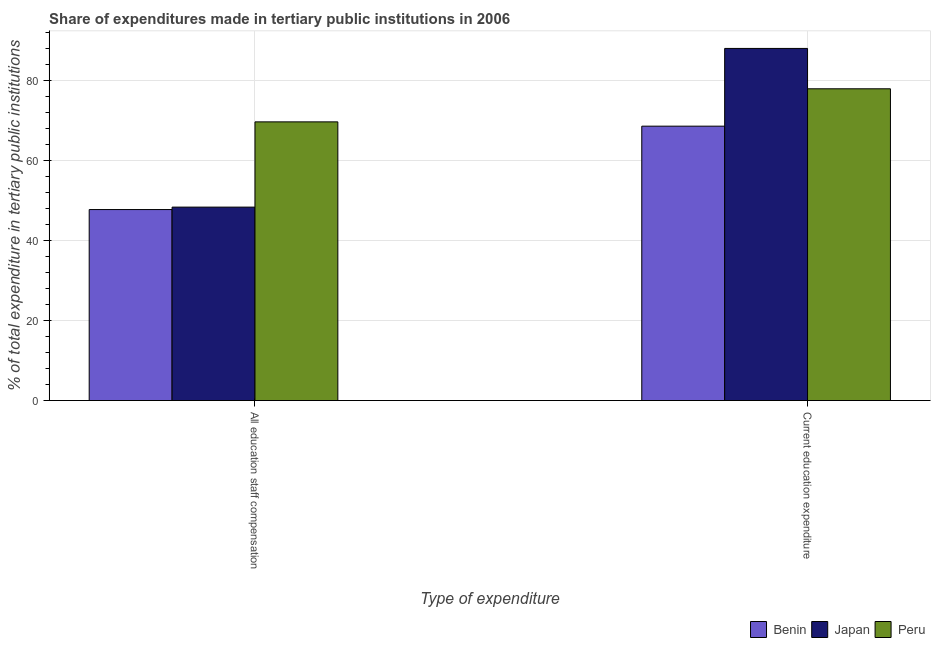How many different coloured bars are there?
Make the answer very short. 3. How many groups of bars are there?
Make the answer very short. 2. How many bars are there on the 1st tick from the left?
Give a very brief answer. 3. What is the label of the 2nd group of bars from the left?
Your answer should be compact. Current education expenditure. What is the expenditure in staff compensation in Benin?
Your answer should be very brief. 47.78. Across all countries, what is the maximum expenditure in staff compensation?
Provide a succinct answer. 69.72. Across all countries, what is the minimum expenditure in staff compensation?
Offer a very short reply. 47.78. In which country was the expenditure in education minimum?
Your answer should be very brief. Benin. What is the total expenditure in staff compensation in the graph?
Provide a short and direct response. 165.9. What is the difference between the expenditure in education in Peru and that in Benin?
Give a very brief answer. 9.35. What is the difference between the expenditure in education in Japan and the expenditure in staff compensation in Peru?
Offer a terse response. 18.37. What is the average expenditure in staff compensation per country?
Offer a very short reply. 55.3. What is the difference between the expenditure in staff compensation and expenditure in education in Peru?
Make the answer very short. -8.27. What is the ratio of the expenditure in staff compensation in Benin to that in Peru?
Make the answer very short. 0.69. In how many countries, is the expenditure in education greater than the average expenditure in education taken over all countries?
Make the answer very short. 1. What does the 3rd bar from the left in Current education expenditure represents?
Provide a succinct answer. Peru. What is the difference between two consecutive major ticks on the Y-axis?
Offer a very short reply. 20. Does the graph contain any zero values?
Your answer should be compact. No. Does the graph contain grids?
Your answer should be very brief. Yes. How are the legend labels stacked?
Your answer should be compact. Horizontal. What is the title of the graph?
Offer a very short reply. Share of expenditures made in tertiary public institutions in 2006. Does "Nigeria" appear as one of the legend labels in the graph?
Provide a succinct answer. No. What is the label or title of the X-axis?
Provide a short and direct response. Type of expenditure. What is the label or title of the Y-axis?
Your answer should be compact. % of total expenditure in tertiary public institutions. What is the % of total expenditure in tertiary public institutions in Benin in All education staff compensation?
Offer a terse response. 47.78. What is the % of total expenditure in tertiary public institutions of Japan in All education staff compensation?
Your answer should be compact. 48.4. What is the % of total expenditure in tertiary public institutions of Peru in All education staff compensation?
Ensure brevity in your answer.  69.72. What is the % of total expenditure in tertiary public institutions of Benin in Current education expenditure?
Offer a very short reply. 68.65. What is the % of total expenditure in tertiary public institutions of Japan in Current education expenditure?
Offer a terse response. 88.09. What is the % of total expenditure in tertiary public institutions of Peru in Current education expenditure?
Offer a very short reply. 77.99. Across all Type of expenditure, what is the maximum % of total expenditure in tertiary public institutions of Benin?
Ensure brevity in your answer.  68.65. Across all Type of expenditure, what is the maximum % of total expenditure in tertiary public institutions in Japan?
Provide a short and direct response. 88.09. Across all Type of expenditure, what is the maximum % of total expenditure in tertiary public institutions in Peru?
Your response must be concise. 77.99. Across all Type of expenditure, what is the minimum % of total expenditure in tertiary public institutions in Benin?
Give a very brief answer. 47.78. Across all Type of expenditure, what is the minimum % of total expenditure in tertiary public institutions of Japan?
Your answer should be very brief. 48.4. Across all Type of expenditure, what is the minimum % of total expenditure in tertiary public institutions in Peru?
Provide a short and direct response. 69.72. What is the total % of total expenditure in tertiary public institutions of Benin in the graph?
Offer a terse response. 116.43. What is the total % of total expenditure in tertiary public institutions in Japan in the graph?
Your answer should be compact. 136.49. What is the total % of total expenditure in tertiary public institutions in Peru in the graph?
Give a very brief answer. 147.71. What is the difference between the % of total expenditure in tertiary public institutions in Benin in All education staff compensation and that in Current education expenditure?
Offer a terse response. -20.86. What is the difference between the % of total expenditure in tertiary public institutions in Japan in All education staff compensation and that in Current education expenditure?
Your answer should be very brief. -39.7. What is the difference between the % of total expenditure in tertiary public institutions of Peru in All education staff compensation and that in Current education expenditure?
Offer a very short reply. -8.27. What is the difference between the % of total expenditure in tertiary public institutions of Benin in All education staff compensation and the % of total expenditure in tertiary public institutions of Japan in Current education expenditure?
Your response must be concise. -40.31. What is the difference between the % of total expenditure in tertiary public institutions of Benin in All education staff compensation and the % of total expenditure in tertiary public institutions of Peru in Current education expenditure?
Keep it short and to the point. -30.21. What is the difference between the % of total expenditure in tertiary public institutions in Japan in All education staff compensation and the % of total expenditure in tertiary public institutions in Peru in Current education expenditure?
Offer a terse response. -29.6. What is the average % of total expenditure in tertiary public institutions in Benin per Type of expenditure?
Your answer should be compact. 58.22. What is the average % of total expenditure in tertiary public institutions of Japan per Type of expenditure?
Give a very brief answer. 68.24. What is the average % of total expenditure in tertiary public institutions of Peru per Type of expenditure?
Provide a succinct answer. 73.86. What is the difference between the % of total expenditure in tertiary public institutions of Benin and % of total expenditure in tertiary public institutions of Japan in All education staff compensation?
Keep it short and to the point. -0.61. What is the difference between the % of total expenditure in tertiary public institutions of Benin and % of total expenditure in tertiary public institutions of Peru in All education staff compensation?
Make the answer very short. -21.94. What is the difference between the % of total expenditure in tertiary public institutions of Japan and % of total expenditure in tertiary public institutions of Peru in All education staff compensation?
Provide a short and direct response. -21.32. What is the difference between the % of total expenditure in tertiary public institutions of Benin and % of total expenditure in tertiary public institutions of Japan in Current education expenditure?
Offer a terse response. -19.44. What is the difference between the % of total expenditure in tertiary public institutions of Benin and % of total expenditure in tertiary public institutions of Peru in Current education expenditure?
Your response must be concise. -9.35. What is the difference between the % of total expenditure in tertiary public institutions of Japan and % of total expenditure in tertiary public institutions of Peru in Current education expenditure?
Your answer should be compact. 10.1. What is the ratio of the % of total expenditure in tertiary public institutions of Benin in All education staff compensation to that in Current education expenditure?
Give a very brief answer. 0.7. What is the ratio of the % of total expenditure in tertiary public institutions in Japan in All education staff compensation to that in Current education expenditure?
Make the answer very short. 0.55. What is the ratio of the % of total expenditure in tertiary public institutions of Peru in All education staff compensation to that in Current education expenditure?
Ensure brevity in your answer.  0.89. What is the difference between the highest and the second highest % of total expenditure in tertiary public institutions in Benin?
Provide a short and direct response. 20.86. What is the difference between the highest and the second highest % of total expenditure in tertiary public institutions of Japan?
Keep it short and to the point. 39.7. What is the difference between the highest and the second highest % of total expenditure in tertiary public institutions in Peru?
Your response must be concise. 8.27. What is the difference between the highest and the lowest % of total expenditure in tertiary public institutions in Benin?
Give a very brief answer. 20.86. What is the difference between the highest and the lowest % of total expenditure in tertiary public institutions in Japan?
Ensure brevity in your answer.  39.7. What is the difference between the highest and the lowest % of total expenditure in tertiary public institutions of Peru?
Your answer should be compact. 8.27. 